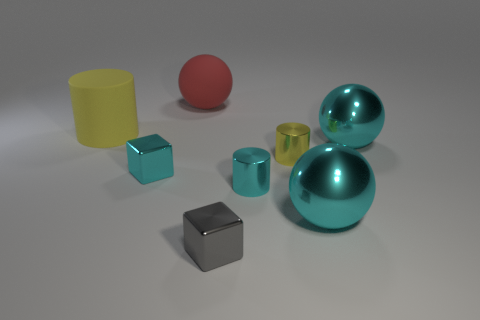Add 1 gray matte cubes. How many objects exist? 9 Subtract all cylinders. How many objects are left? 5 Subtract 1 cyan spheres. How many objects are left? 7 Subtract all cyan cylinders. Subtract all spheres. How many objects are left? 4 Add 4 red objects. How many red objects are left? 5 Add 4 gray things. How many gray things exist? 5 